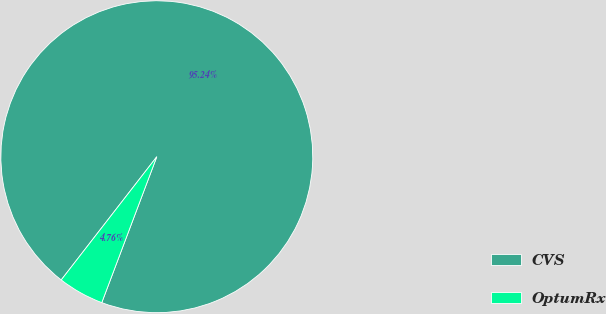<chart> <loc_0><loc_0><loc_500><loc_500><pie_chart><fcel>CVS<fcel>OptumRx<nl><fcel>95.24%<fcel>4.76%<nl></chart> 